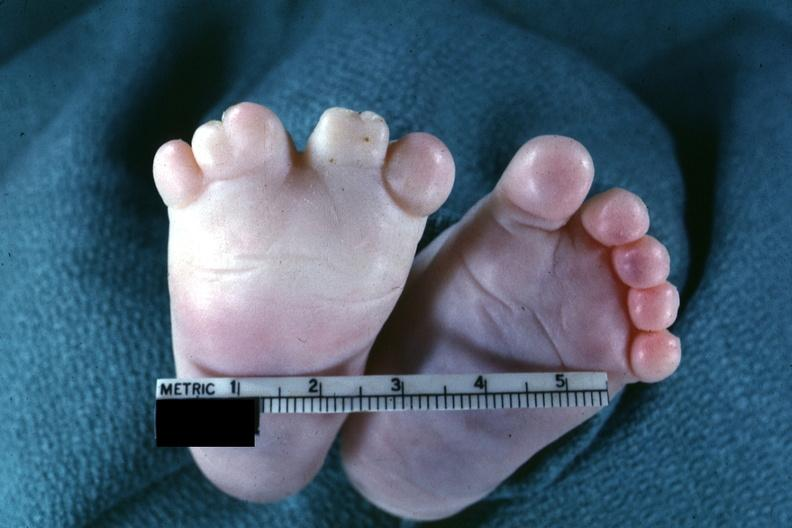what are present?
Answer the question using a single word or phrase. Extremities 